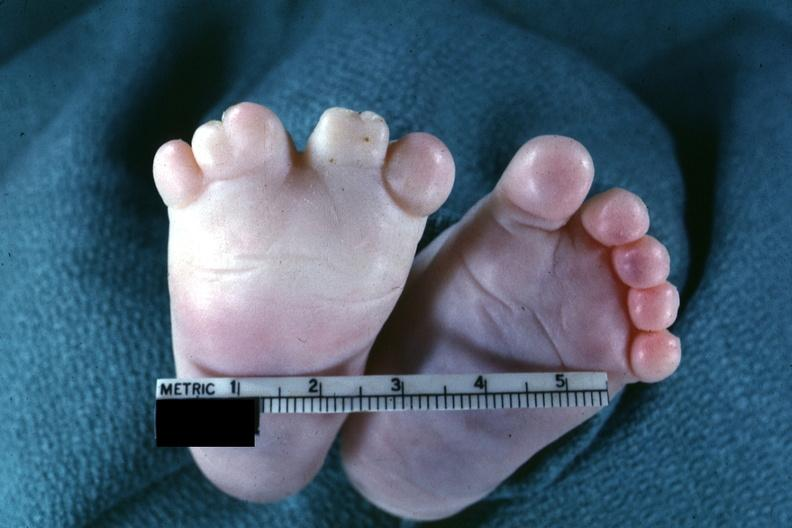what are present?
Answer the question using a single word or phrase. Extremities 